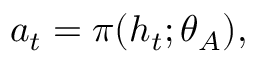<formula> <loc_0><loc_0><loc_500><loc_500>a _ { t } = \pi ( h _ { t } ; \theta _ { A } ) ,</formula> 